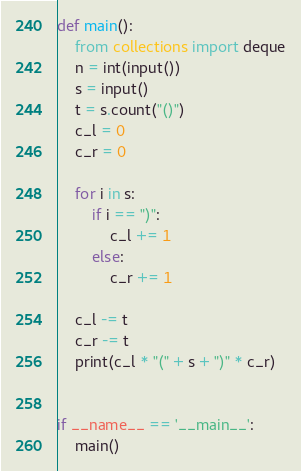<code> <loc_0><loc_0><loc_500><loc_500><_Python_>def main():
    from collections import deque
    n = int(input())
    s = input()
    t = s.count("()")
    c_l = 0
    c_r = 0

    for i in s:
        if i == ")":
            c_l += 1
        else:
            c_r += 1

    c_l -= t
    c_r -= t
    print(c_l * "(" + s + ")" * c_r)


if __name__ == '__main__':
    main()
</code> 